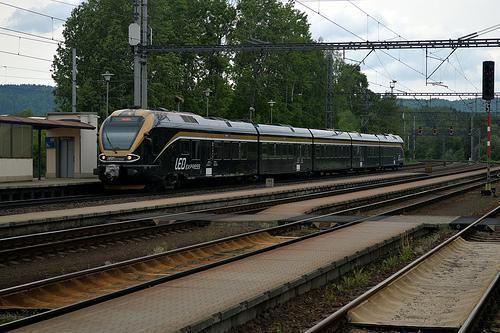How many trains are there?
Give a very brief answer. 1. 